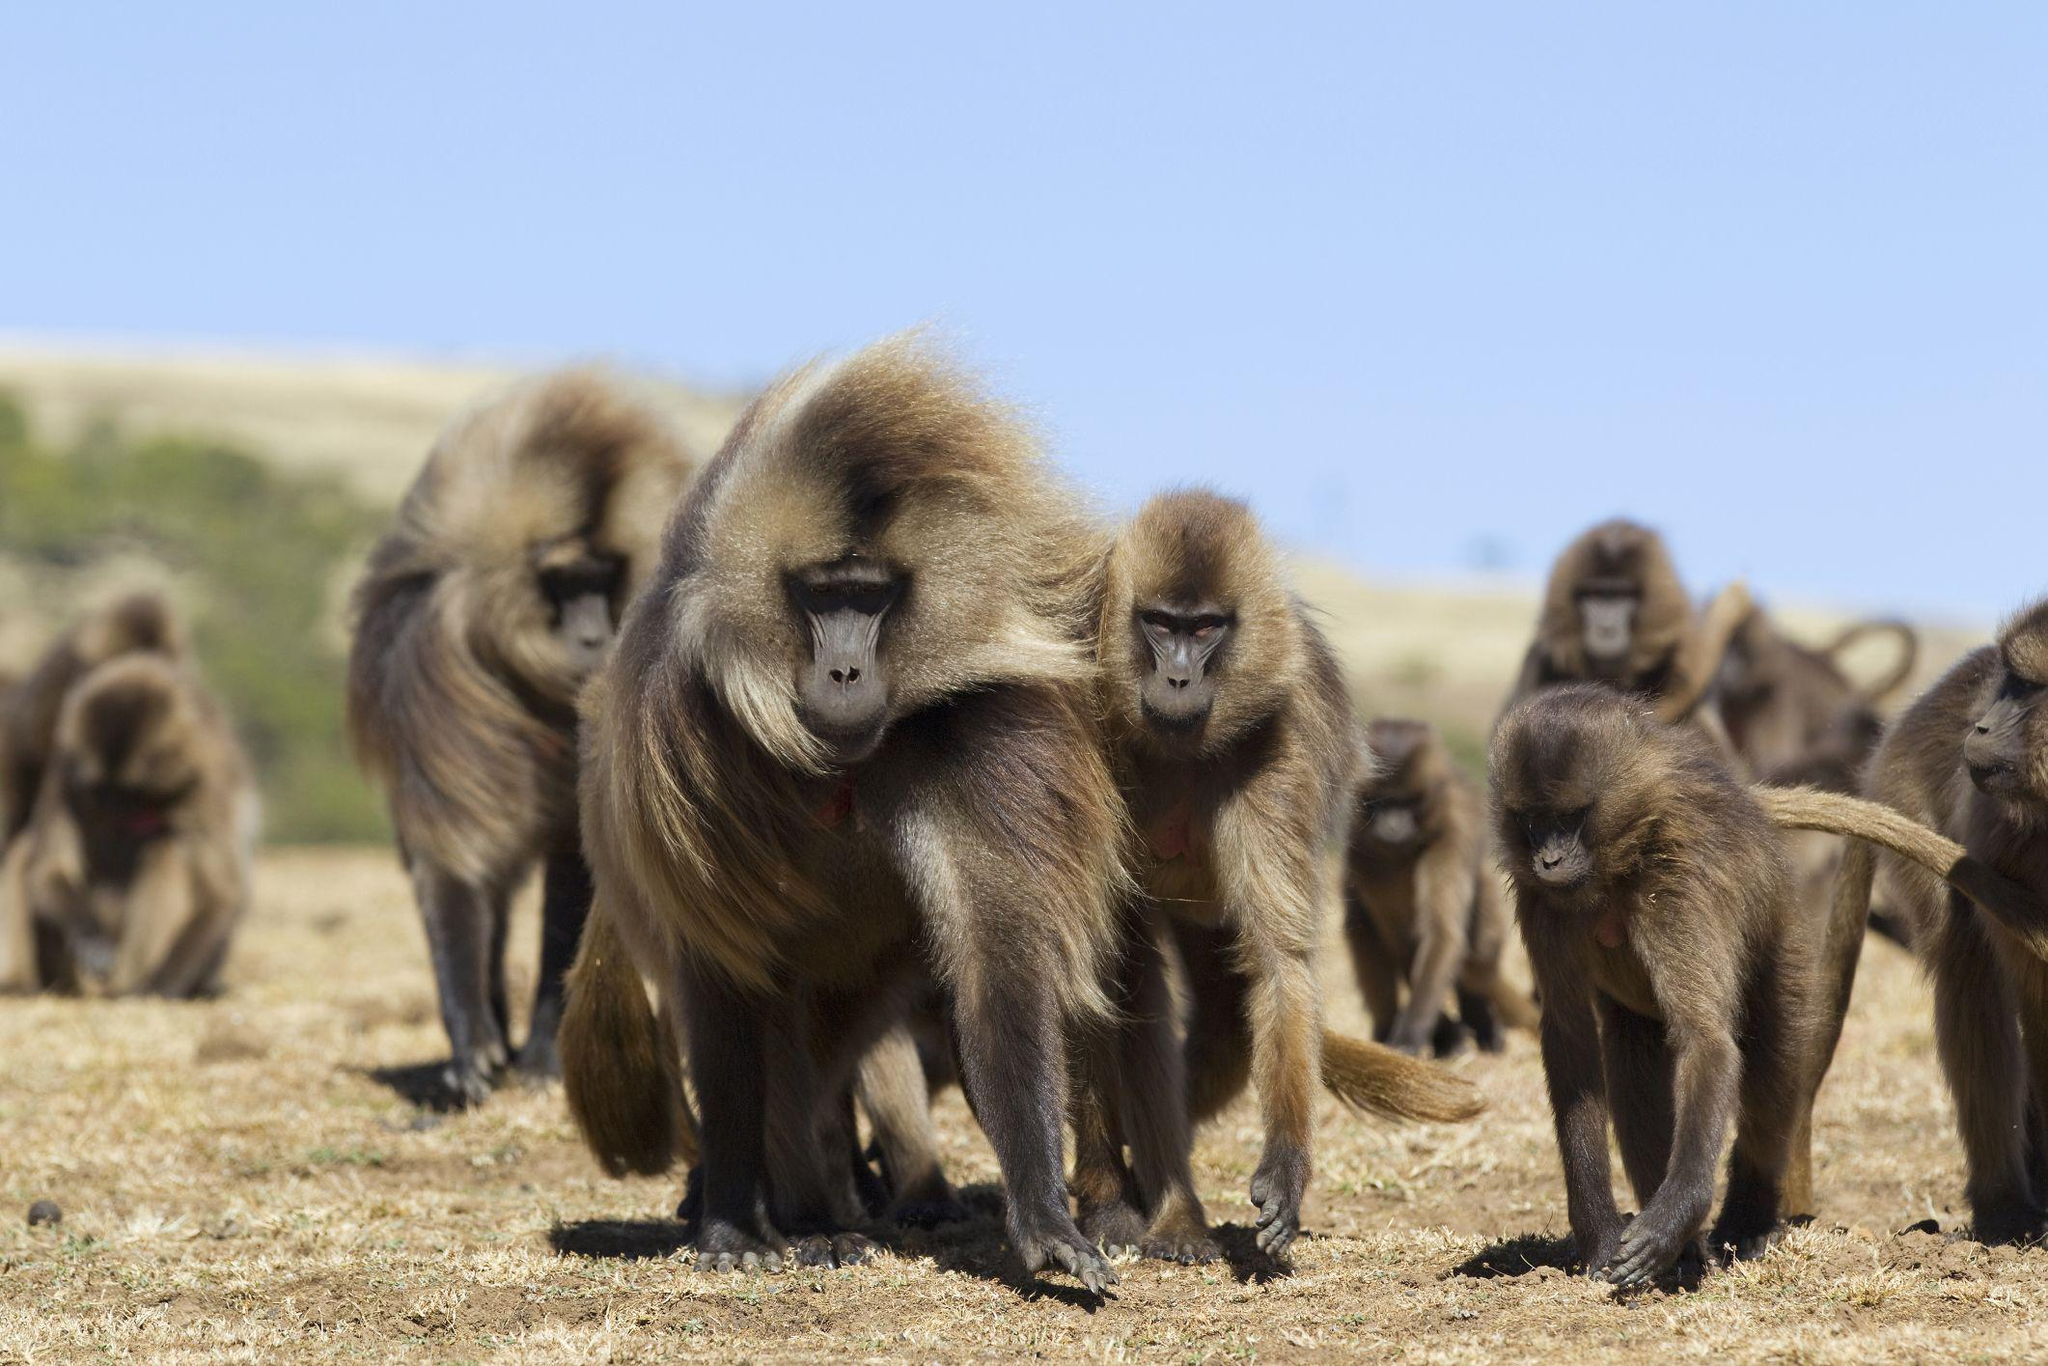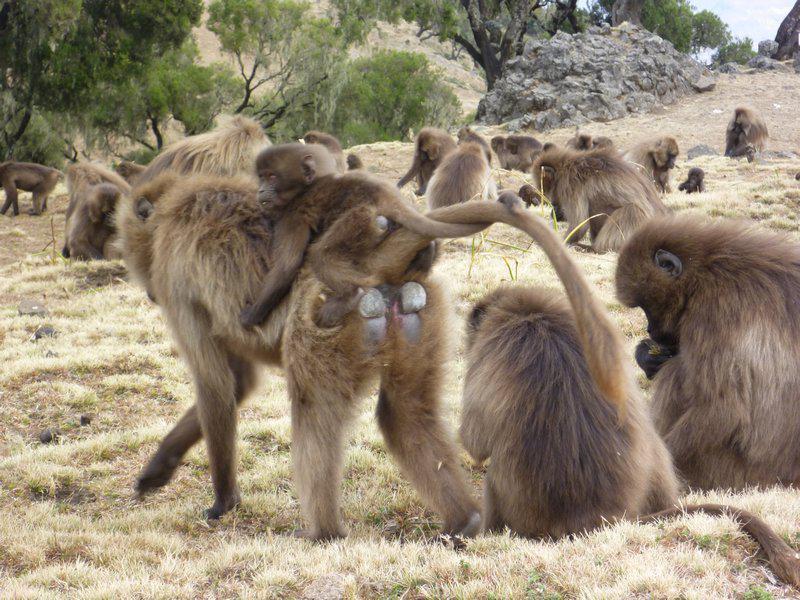The first image is the image on the left, the second image is the image on the right. Assess this claim about the two images: "There's no more than two monkeys in the right image.". Correct or not? Answer yes or no. No. The first image is the image on the left, the second image is the image on the right. For the images displayed, is the sentence "The right image contains fewer than a third of the number of baboons on the left." factually correct? Answer yes or no. No. 